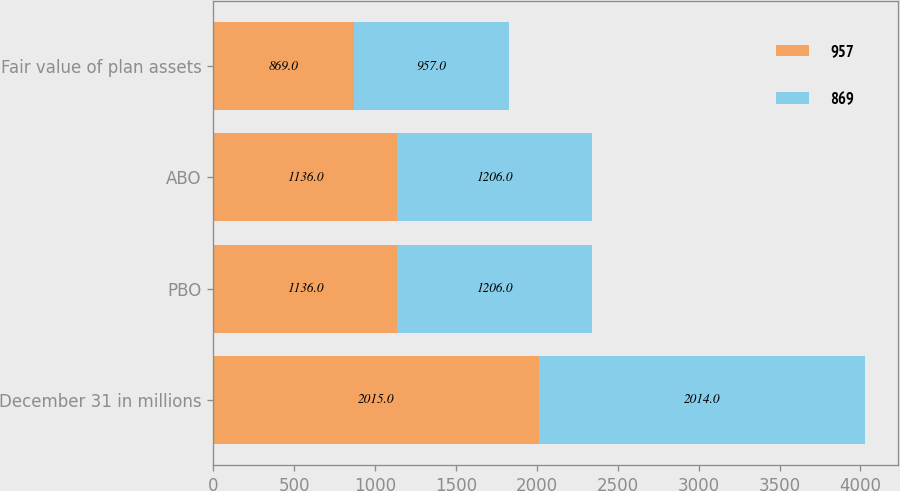Convert chart to OTSL. <chart><loc_0><loc_0><loc_500><loc_500><stacked_bar_chart><ecel><fcel>December 31 in millions<fcel>PBO<fcel>ABO<fcel>Fair value of plan assets<nl><fcel>957<fcel>2015<fcel>1136<fcel>1136<fcel>869<nl><fcel>869<fcel>2014<fcel>1206<fcel>1206<fcel>957<nl></chart> 